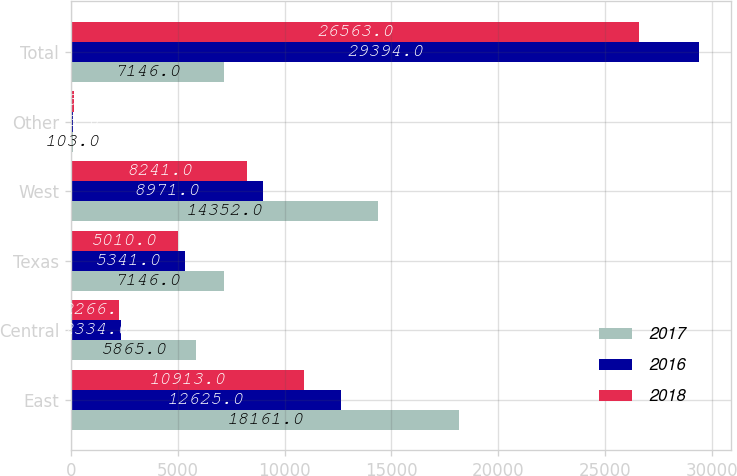Convert chart. <chart><loc_0><loc_0><loc_500><loc_500><stacked_bar_chart><ecel><fcel>East<fcel>Central<fcel>Texas<fcel>West<fcel>Other<fcel>Total<nl><fcel>2017<fcel>18161<fcel>5865<fcel>7146<fcel>14352<fcel>103<fcel>7146<nl><fcel>2016<fcel>12625<fcel>2334<fcel>5341<fcel>8971<fcel>123<fcel>29394<nl><fcel>2018<fcel>10913<fcel>2266<fcel>5010<fcel>8241<fcel>133<fcel>26563<nl></chart> 